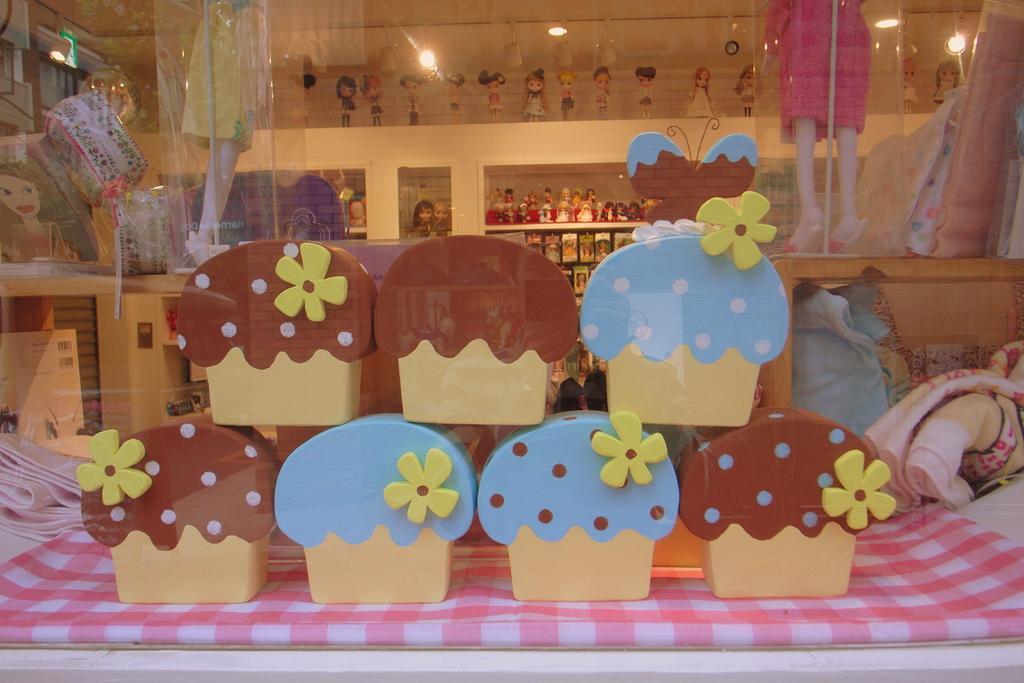Describe this image in one or two sentences. In this picture we can see few things on the table, in the background we can find few lights and toys in the racks. 